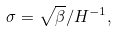<formula> <loc_0><loc_0><loc_500><loc_500>\sigma = \sqrt { \beta } / H ^ { - 1 } ,</formula> 